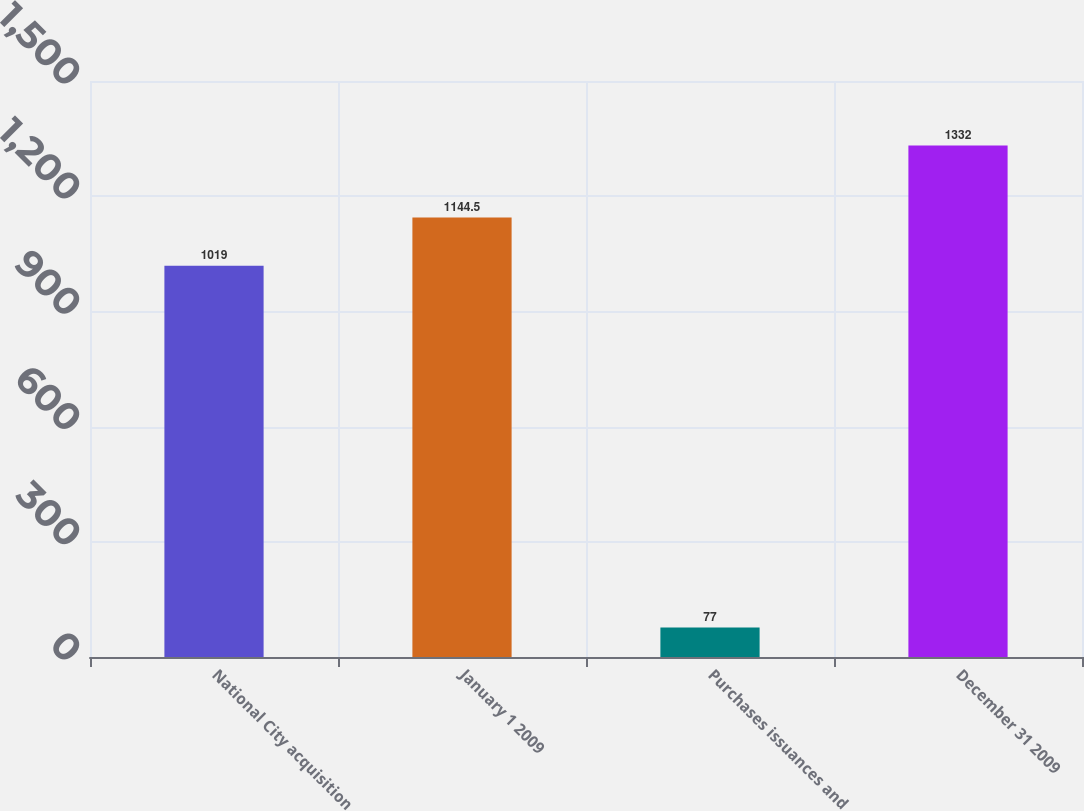<chart> <loc_0><loc_0><loc_500><loc_500><bar_chart><fcel>National City acquisition<fcel>January 1 2009<fcel>Purchases issuances and<fcel>December 31 2009<nl><fcel>1019<fcel>1144.5<fcel>77<fcel>1332<nl></chart> 